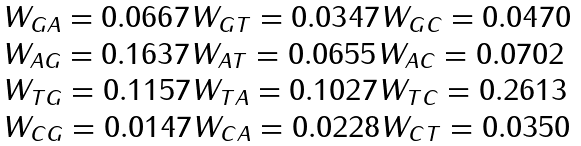<formula> <loc_0><loc_0><loc_500><loc_500>\begin{array} { l } W _ { G A } = 0 . 0 6 6 7 W _ { G T } = 0 . 0 3 4 7 W _ { G C } = 0 . 0 4 7 0 \\ W _ { A G } = 0 . 1 6 3 7 W _ { A T } = 0 . 0 6 5 5 W _ { A C } = 0 . 0 7 0 2 \\ W _ { T G } = 0 . 1 1 5 7 W _ { T A } = 0 . 1 0 2 7 W _ { T C } = 0 . 2 6 1 3 \\ W _ { C G } = 0 . 0 1 4 7 W _ { C A } = 0 . 0 2 2 8 W _ { C T } = 0 . 0 3 5 0 \\ \end{array}</formula> 